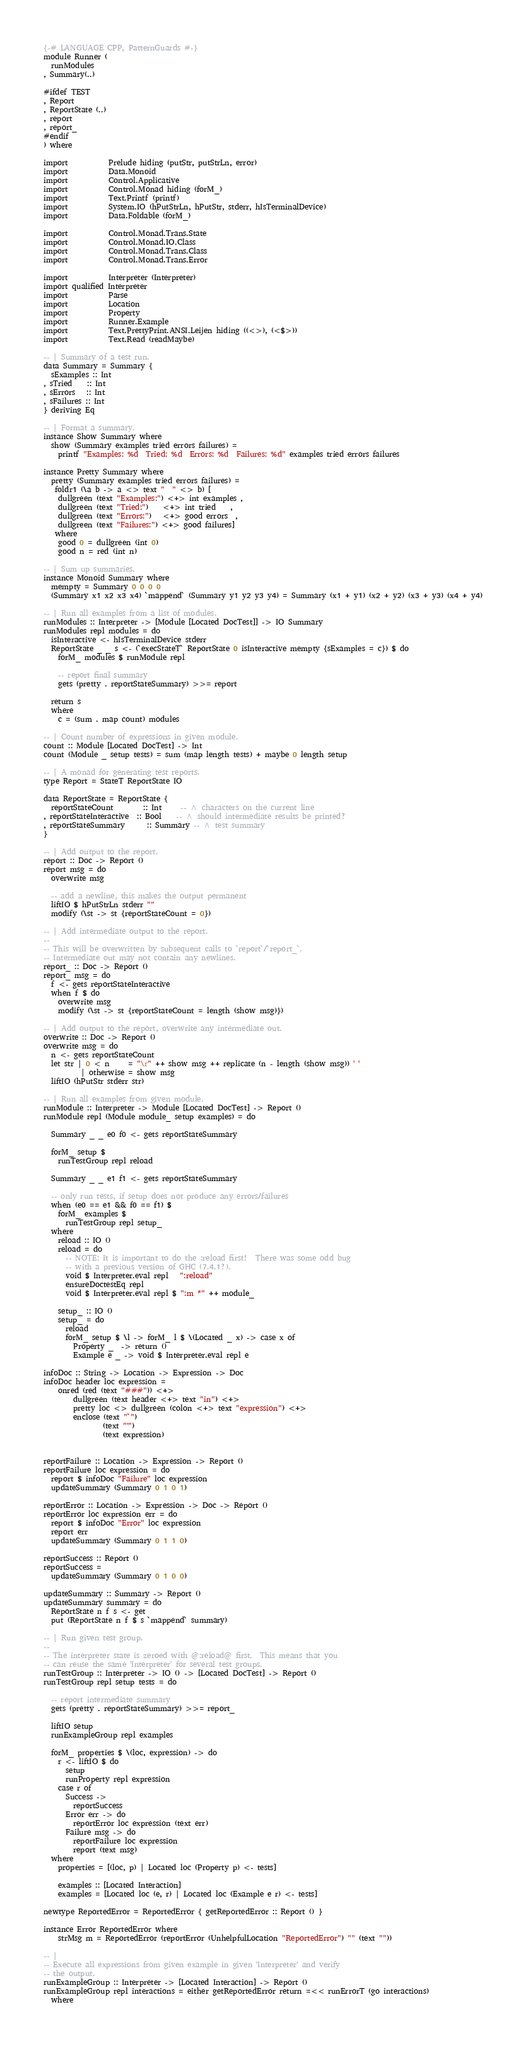<code> <loc_0><loc_0><loc_500><loc_500><_Haskell_>{-# LANGUAGE CPP, PatternGuards #-}
module Runner (
  runModules
, Summary(..)

#ifdef TEST
, Report
, ReportState (..)
, report
, report_
#endif
) where

import           Prelude hiding (putStr, putStrLn, error)
import           Data.Monoid
import           Control.Applicative
import           Control.Monad hiding (forM_)
import           Text.Printf (printf)
import           System.IO (hPutStrLn, hPutStr, stderr, hIsTerminalDevice)
import           Data.Foldable (forM_)

import           Control.Monad.Trans.State
import           Control.Monad.IO.Class
import           Control.Monad.Trans.Class
import           Control.Monad.Trans.Error

import           Interpreter (Interpreter)
import qualified Interpreter
import           Parse
import           Location
import           Property
import           Runner.Example
import           Text.PrettyPrint.ANSI.Leijen hiding ((<>), (<$>))
import           Text.Read (readMaybe)

-- | Summary of a test run.
data Summary = Summary {
  sExamples :: Int
, sTried    :: Int
, sErrors   :: Int
, sFailures :: Int
} deriving Eq

-- | Format a summary.
instance Show Summary where
  show (Summary examples tried errors failures) =
    printf "Examples: %d  Tried: %d  Errors: %d  Failures: %d" examples tried errors failures

instance Pretty Summary where
  pretty (Summary examples tried errors failures) =
   foldr1 (\a b -> a <> text "  " <> b) [
    dullgreen (text "Examples:") <+> int examples ,
    dullgreen (text "Tried:")    <+> int tried    ,
    dullgreen (text "Errors:")   <+> good errors  ,
    dullgreen (text "Failures:") <+> good failures]
   where
    good 0 = dullgreen (int 0)
    good n = red (int n)

-- | Sum up summaries.
instance Monoid Summary where
  mempty = Summary 0 0 0 0
  (Summary x1 x2 x3 x4) `mappend` (Summary y1 y2 y3 y4) = Summary (x1 + y1) (x2 + y2) (x3 + y3) (x4 + y4)

-- | Run all examples from a list of modules.
runModules :: Interpreter -> [Module [Located DocTest]] -> IO Summary
runModules repl modules = do
  isInteractive <- hIsTerminalDevice stderr
  ReportState _ _ s <- (`execStateT` ReportState 0 isInteractive mempty {sExamples = c}) $ do
    forM_ modules $ runModule repl

    -- report final summary
    gets (pretty . reportStateSummary) >>= report

  return s
  where
    c = (sum . map count) modules

-- | Count number of expressions in given module.
count :: Module [Located DocTest] -> Int
count (Module _ setup tests) = sum (map length tests) + maybe 0 length setup

-- | A monad for generating test reports.
type Report = StateT ReportState IO

data ReportState = ReportState {
  reportStateCount        :: Int     -- ^ characters on the current line
, reportStateInteractive  :: Bool    -- ^ should intermediate results be printed?
, reportStateSummary      :: Summary -- ^ test summary
}

-- | Add output to the report.
report :: Doc -> Report ()
report msg = do
  overwrite msg

  -- add a newline, this makes the output permanent
  liftIO $ hPutStrLn stderr ""
  modify (\st -> st {reportStateCount = 0})

-- | Add intermediate output to the report.
--
-- This will be overwritten by subsequent calls to `report`/`report_`.
-- Intermediate out may not contain any newlines.
report_ :: Doc -> Report ()
report_ msg = do
  f <- gets reportStateInteractive
  when f $ do
    overwrite msg
    modify (\st -> st {reportStateCount = length (show msg)})

-- | Add output to the report, overwrite any intermediate out.
overwrite :: Doc -> Report ()
overwrite msg = do
  n <- gets reportStateCount
  let str | 0 < n     = "\r" ++ show msg ++ replicate (n - length (show msg)) ' '
          | otherwise = show msg
  liftIO (hPutStr stderr str)

-- | Run all examples from given module.
runModule :: Interpreter -> Module [Located DocTest] -> Report ()
runModule repl (Module module_ setup examples) = do

  Summary _ _ e0 f0 <- gets reportStateSummary

  forM_ setup $
    runTestGroup repl reload

  Summary _ _ e1 f1 <- gets reportStateSummary

  -- only run tests, if setup does not produce any errors/failures
  when (e0 == e1 && f0 == f1) $
    forM_ examples $
      runTestGroup repl setup_
  where
    reload :: IO ()
    reload = do
      -- NOTE: It is important to do the :reload first!  There was some odd bug
      -- with a previous version of GHC (7.4.1?).
      void $ Interpreter.eval repl   ":reload"
      ensureDoctestEq repl
      void $ Interpreter.eval repl $ ":m *" ++ module_

    setup_ :: IO ()
    setup_ = do
      reload
      forM_ setup $ \l -> forM_ l $ \(Located _ x) -> case x of
        Property _  -> return ()
        Example e _ -> void $ Interpreter.eval repl e

infoDoc :: String -> Location -> Expression -> Doc
infoDoc header loc expression =
    onred (red (text "###")) <+> 
        dullgreen (text header <+> text "in") <+>
        pretty loc <> dullgreen (colon <+> text "expression") <+>
        enclose (text "`")
                (text "'")
                (text expression)


reportFailure :: Location -> Expression -> Report ()
reportFailure loc expression = do
  report $ infoDoc "Failure" loc expression
  updateSummary (Summary 0 1 0 1)

reportError :: Location -> Expression -> Doc -> Report ()
reportError loc expression err = do
  report $ infoDoc "Error" loc expression
  report err
  updateSummary (Summary 0 1 1 0)

reportSuccess :: Report ()
reportSuccess =
  updateSummary (Summary 0 1 0 0)

updateSummary :: Summary -> Report ()
updateSummary summary = do
  ReportState n f s <- get
  put (ReportState n f $ s `mappend` summary)

-- | Run given test group.
--
-- The interpreter state is zeroed with @:reload@ first.  This means that you
-- can reuse the same 'Interpreter' for several test groups.
runTestGroup :: Interpreter -> IO () -> [Located DocTest] -> Report ()
runTestGroup repl setup tests = do

  -- report intermediate summary
  gets (pretty . reportStateSummary) >>= report_

  liftIO setup
  runExampleGroup repl examples

  forM_ properties $ \(loc, expression) -> do
    r <- liftIO $ do
      setup
      runProperty repl expression
    case r of
      Success ->
        reportSuccess
      Error err -> do
        reportError loc expression (text err)
      Failure msg -> do
        reportFailure loc expression
        report (text msg)
  where
    properties = [(loc, p) | Located loc (Property p) <- tests]

    examples :: [Located Interaction]
    examples = [Located loc (e, r) | Located loc (Example e r) <- tests]

newtype ReportedError = ReportedError { getReportedError :: Report () }

instance Error ReportedError where
    strMsg m = ReportedError (reportError (UnhelpfulLocation "ReportedError") "" (text ""))

-- |
-- Execute all expressions from given example in given 'Interpreter' and verify
-- the output.
runExampleGroup :: Interpreter -> [Located Interaction] -> Report ()
runExampleGroup repl interactions = either getReportedError return =<< runErrorT (go interactions)
  where
</code> 